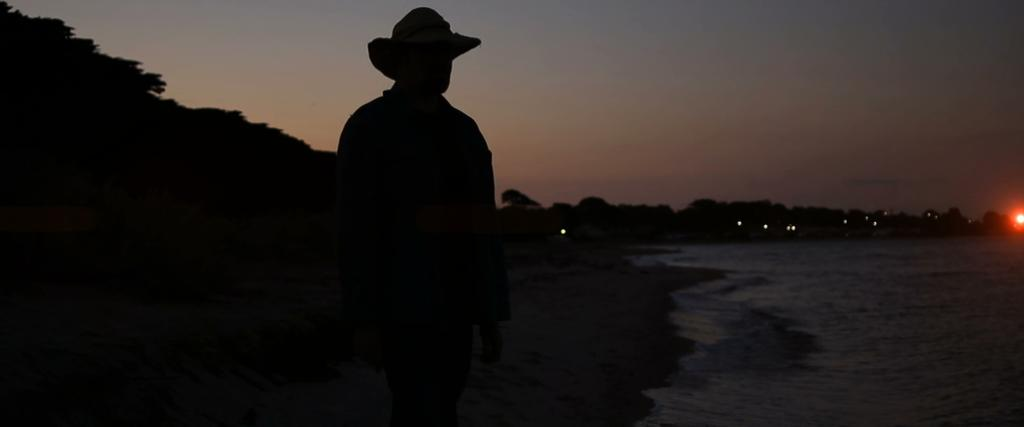Who or what is present in the image? There is a person in the image. What type of natural environment is visible in the image? There are trees and water in the image. How would you describe the lighting in the image? The overall setting is dark. What type of veil is the father wearing in the image? There is no father or veil present in the image. 